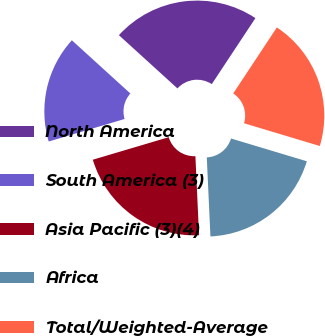Convert chart. <chart><loc_0><loc_0><loc_500><loc_500><pie_chart><fcel>North America<fcel>South America (3)<fcel>Asia Pacific (3)(4)<fcel>Africa<fcel>Total/Weighted-Average<nl><fcel>22.55%<fcel>16.34%<fcel>21.14%<fcel>19.62%<fcel>20.35%<nl></chart> 